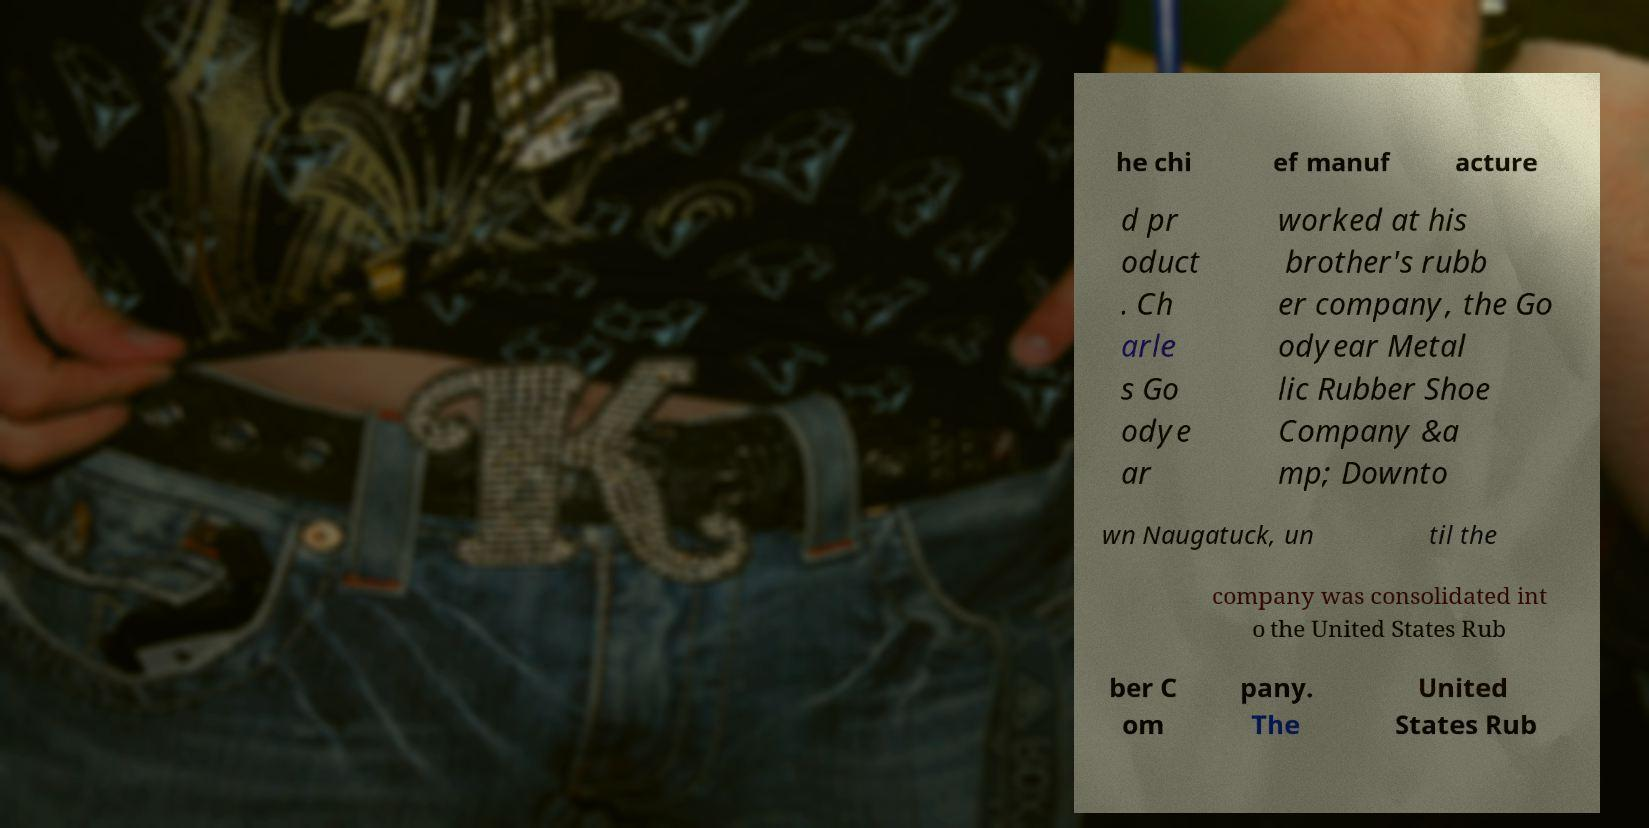Please identify and transcribe the text found in this image. he chi ef manuf acture d pr oduct . Ch arle s Go odye ar worked at his brother's rubb er company, the Go odyear Metal lic Rubber Shoe Company &a mp; Downto wn Naugatuck, un til the company was consolidated int o the United States Rub ber C om pany. The United States Rub 